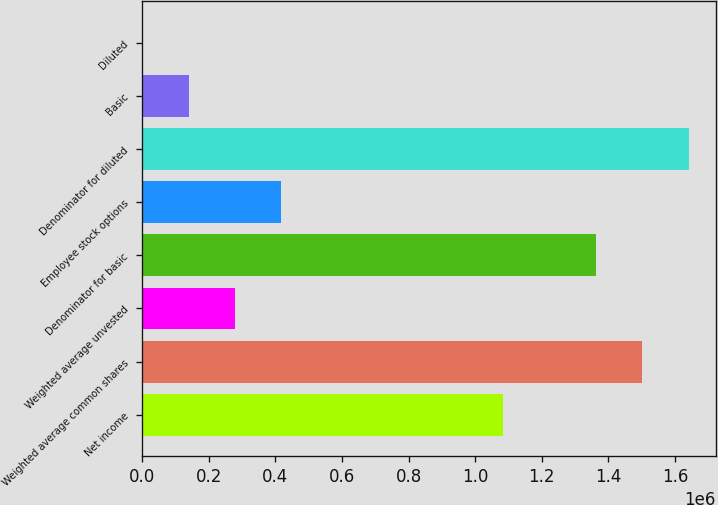<chart> <loc_0><loc_0><loc_500><loc_500><bar_chart><fcel>Net income<fcel>Weighted average common shares<fcel>Weighted average unvested<fcel>Denominator for basic<fcel>Employee stock options<fcel>Denominator for diluted<fcel>Basic<fcel>Diluted<nl><fcel>1.08204e+06<fcel>1.5011e+06<fcel>278776<fcel>1.36171e+06<fcel>418163<fcel>1.64048e+06<fcel>139388<fcel>0.78<nl></chart> 